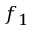<formula> <loc_0><loc_0><loc_500><loc_500>f _ { 1 }</formula> 